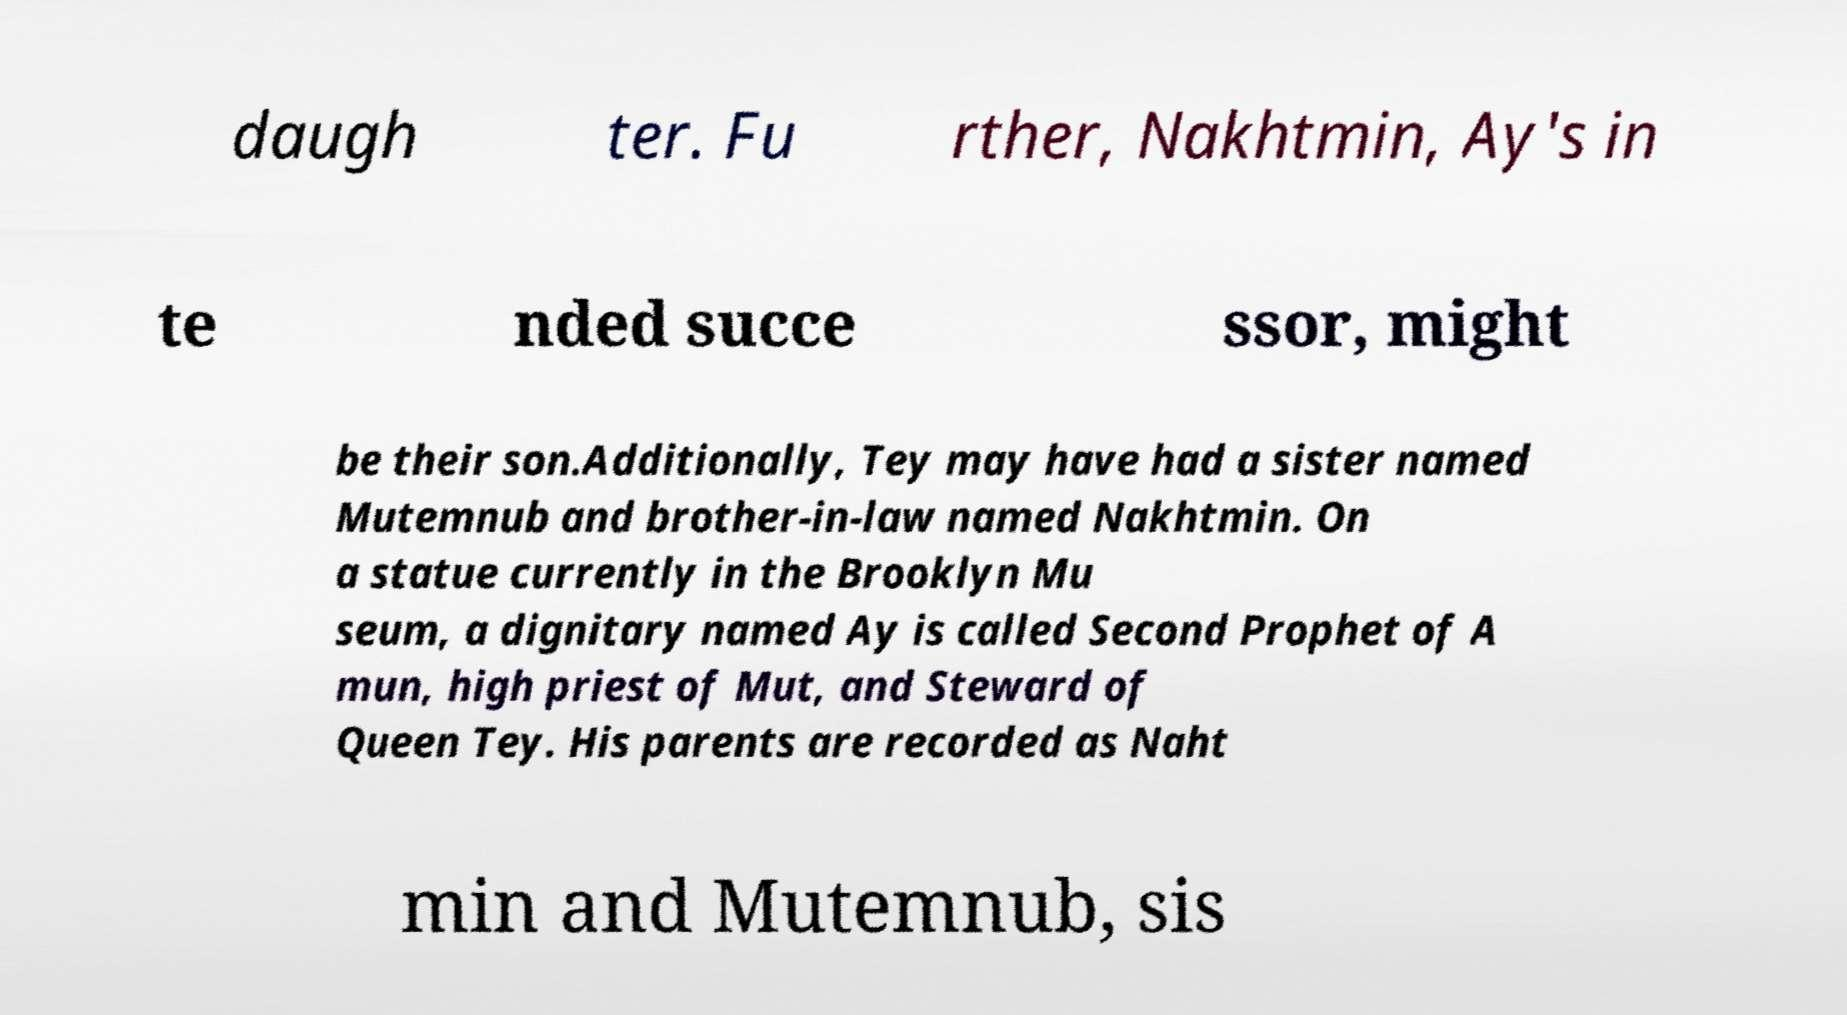Please identify and transcribe the text found in this image. daugh ter. Fu rther, Nakhtmin, Ay's in te nded succe ssor, might be their son.Additionally, Tey may have had a sister named Mutemnub and brother-in-law named Nakhtmin. On a statue currently in the Brooklyn Mu seum, a dignitary named Ay is called Second Prophet of A mun, high priest of Mut, and Steward of Queen Tey. His parents are recorded as Naht min and Mutemnub, sis 